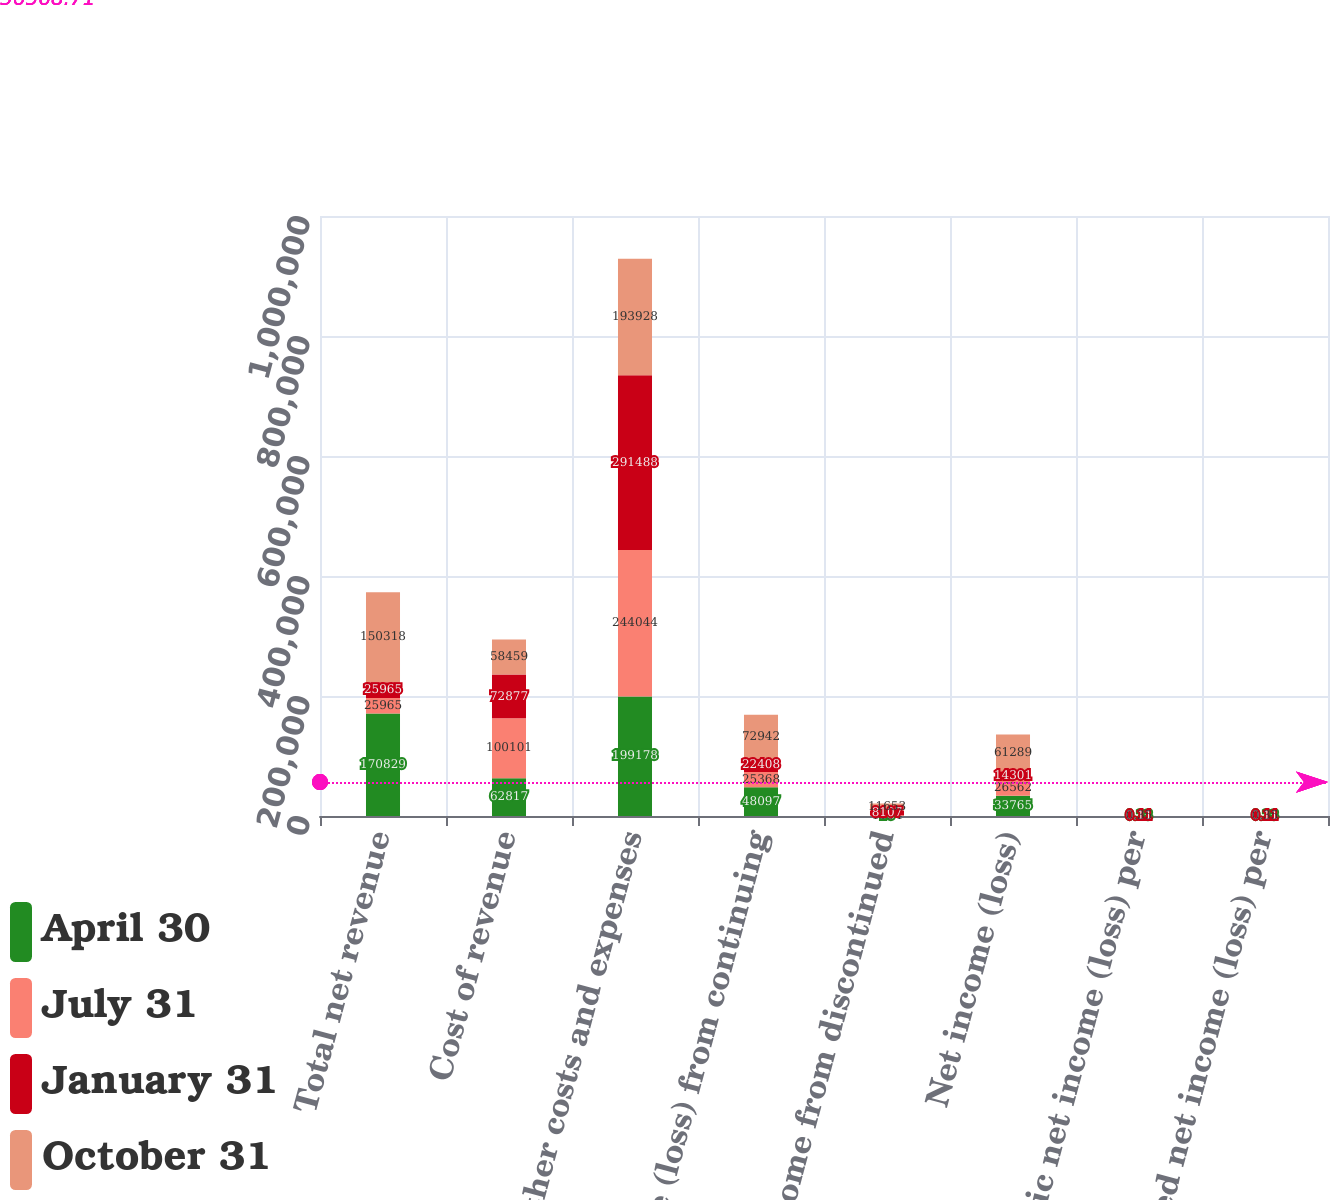Convert chart to OTSL. <chart><loc_0><loc_0><loc_500><loc_500><stacked_bar_chart><ecel><fcel>Total net revenue<fcel>Cost of revenue<fcel>All other costs and expenses<fcel>Income (loss) from continuing<fcel>Net income from discontinued<fcel>Net income (loss)<fcel>Basic net income (loss) per<fcel>Diluted net income (loss) per<nl><fcel>April 30<fcel>170829<fcel>62817<fcel>199178<fcel>48097<fcel>18<fcel>33765<fcel>0.23<fcel>0.23<nl><fcel>July 31<fcel>25965<fcel>100101<fcel>244044<fcel>25368<fcel>1194<fcel>26562<fcel>0.12<fcel>0.12<nl><fcel>January 31<fcel>25965<fcel>72877<fcel>291488<fcel>22408<fcel>8107<fcel>14301<fcel>0.11<fcel>0.11<nl><fcel>October 31<fcel>150318<fcel>58459<fcel>193928<fcel>72942<fcel>11653<fcel>61289<fcel>0.35<fcel>0.35<nl></chart> 